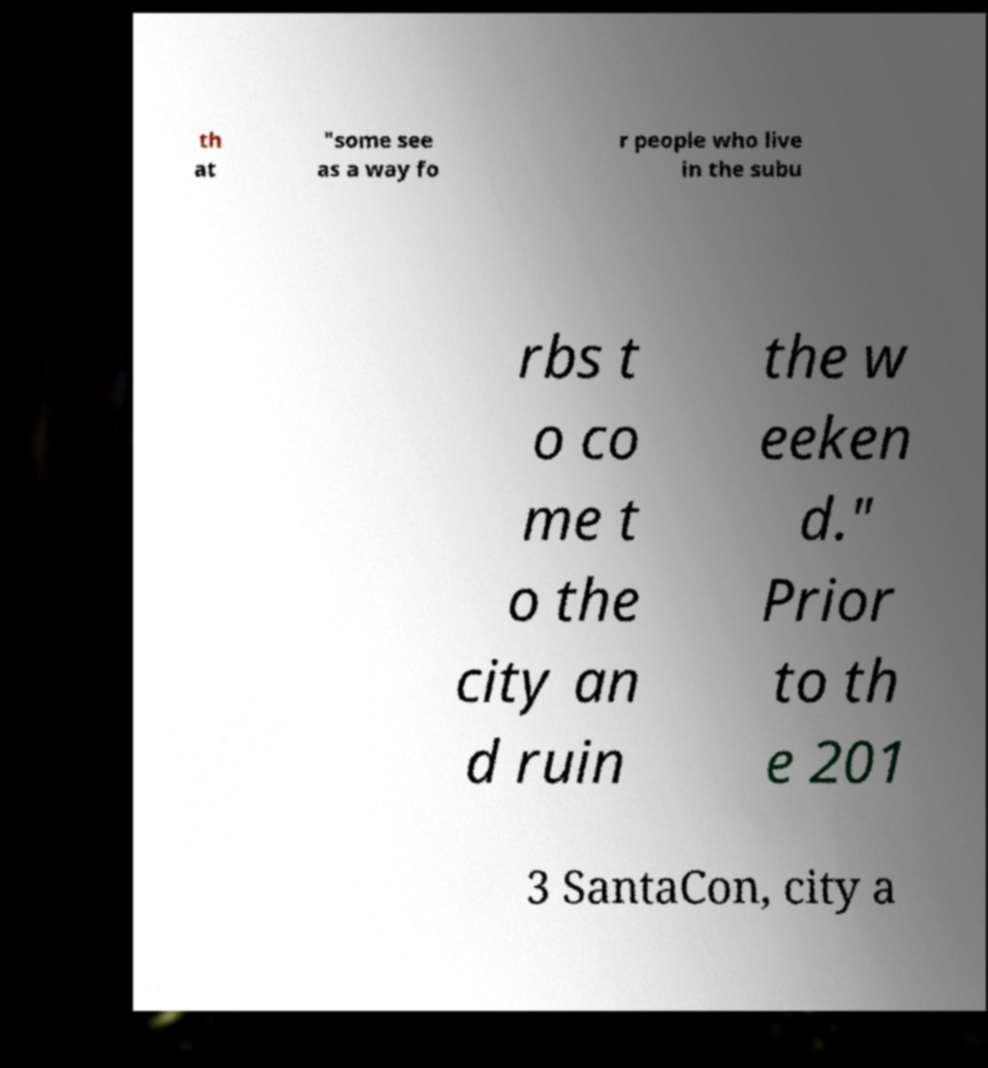Please read and relay the text visible in this image. What does it say? th at "some see as a way fo r people who live in the subu rbs t o co me t o the city an d ruin the w eeken d." Prior to th e 201 3 SantaCon, city a 